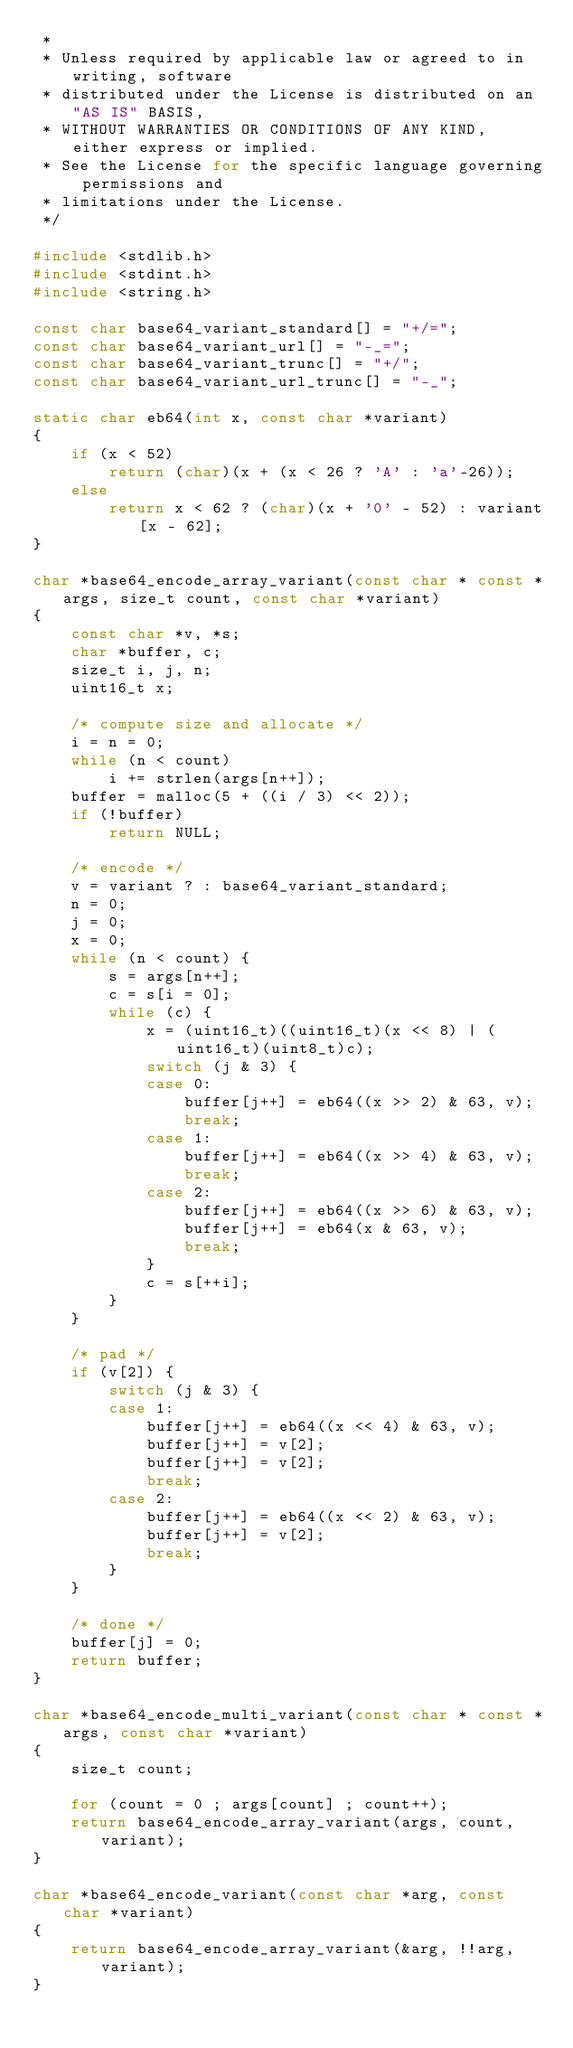Convert code to text. <code><loc_0><loc_0><loc_500><loc_500><_C_> *
 * Unless required by applicable law or agreed to in writing, software
 * distributed under the License is distributed on an "AS IS" BASIS,
 * WITHOUT WARRANTIES OR CONDITIONS OF ANY KIND, either express or implied.
 * See the License for the specific language governing permissions and
 * limitations under the License.
 */

#include <stdlib.h>
#include <stdint.h>
#include <string.h>

const char base64_variant_standard[] = "+/=";
const char base64_variant_url[] = "-_=";
const char base64_variant_trunc[] = "+/";
const char base64_variant_url_trunc[] = "-_";

static char eb64(int x, const char *variant)
{
	if (x < 52)
		return (char)(x + (x < 26 ? 'A' : 'a'-26));
	else
		return x < 62 ? (char)(x + '0' - 52) : variant[x - 62];
}

char *base64_encode_array_variant(const char * const *args, size_t count, const char *variant)
{
	const char *v, *s;
	char *buffer, c;
	size_t i, j, n;
	uint16_t x;

	/* compute size and allocate */
	i = n = 0;
	while (n < count)
		i += strlen(args[n++]);
	buffer = malloc(5 + ((i / 3) << 2));
	if (!buffer)
		return NULL;

	/* encode */
	v = variant ? : base64_variant_standard;
	n = 0;
	j = 0;
	x = 0;
	while (n < count) {
		s = args[n++];
		c = s[i = 0];
		while (c) {
			x = (uint16_t)((uint16_t)(x << 8) | (uint16_t)(uint8_t)c);
			switch (j & 3) {
			case 0:
				buffer[j++] = eb64((x >> 2) & 63, v);
				break;
			case 1:
				buffer[j++] = eb64((x >> 4) & 63, v);
				break;
			case 2:
				buffer[j++] = eb64((x >> 6) & 63, v);
				buffer[j++] = eb64(x & 63, v);
				break;
			}
			c = s[++i];
		}
	}

	/* pad */
	if (v[2]) {
		switch (j & 3) {
		case 1:
			buffer[j++] = eb64((x << 4) & 63, v);
			buffer[j++] = v[2];
			buffer[j++] = v[2];
			break;
		case 2:
			buffer[j++] = eb64((x << 2) & 63, v);
			buffer[j++] = v[2];
			break;
		}
	}

	/* done */
	buffer[j] = 0;
	return buffer;
}

char *base64_encode_multi_variant(const char * const *args, const char *variant)
{
	size_t count;

	for (count = 0 ; args[count] ; count++);
	return base64_encode_array_variant(args, count, variant);
}

char *base64_encode_variant(const char *arg, const char *variant)
{
	return base64_encode_array_variant(&arg, !!arg, variant);
}

</code> 